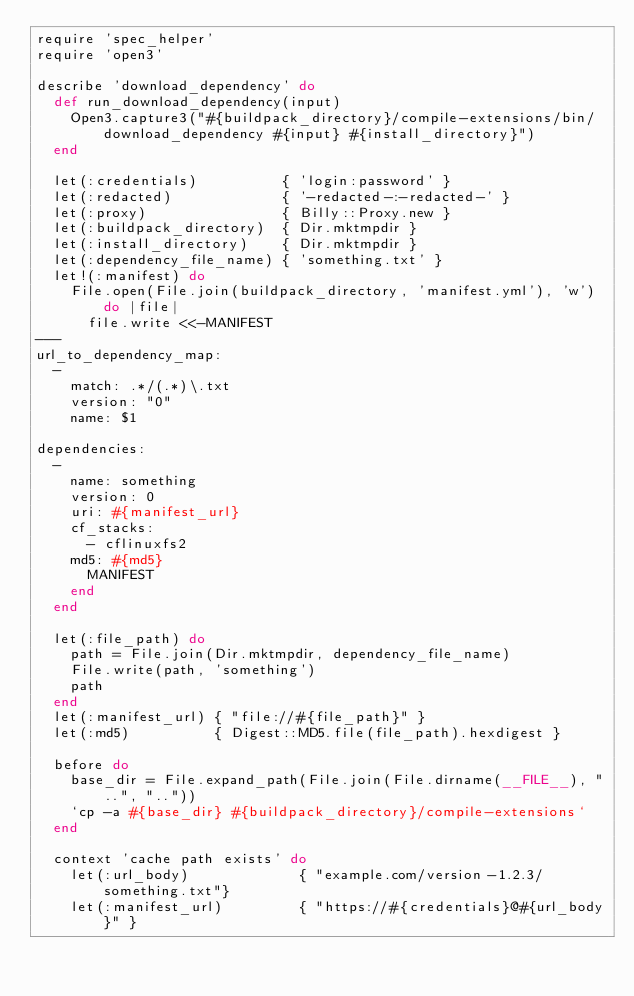Convert code to text. <code><loc_0><loc_0><loc_500><loc_500><_Ruby_>require 'spec_helper'
require 'open3'

describe 'download_dependency' do
  def run_download_dependency(input)
    Open3.capture3("#{buildpack_directory}/compile-extensions/bin/download_dependency #{input} #{install_directory}")
  end

  let(:credentials)          { 'login:password' }
  let(:redacted)             { '-redacted-:-redacted-' }
  let(:proxy)                { Billy::Proxy.new }
  let(:buildpack_directory)  { Dir.mktmpdir }
  let(:install_directory)    { Dir.mktmpdir }
  let(:dependency_file_name) { 'something.txt' }
  let!(:manifest) do
    File.open(File.join(buildpack_directory, 'manifest.yml'), 'w') do |file|
      file.write <<-MANIFEST
---
url_to_dependency_map:
  -
    match: .*/(.*)\.txt
    version: "0"
    name: $1

dependencies:
  -
    name: something
    version: 0
    uri: #{manifest_url}
    cf_stacks:
      - cflinuxfs2
    md5: #{md5}
      MANIFEST
    end
  end

  let(:file_path) do
    path = File.join(Dir.mktmpdir, dependency_file_name)
    File.write(path, 'something')
    path
  end
  let(:manifest_url) { "file://#{file_path}" }
  let(:md5)          { Digest::MD5.file(file_path).hexdigest }

  before do
    base_dir = File.expand_path(File.join(File.dirname(__FILE__), "..", ".."))
    `cp -a #{base_dir} #{buildpack_directory}/compile-extensions`
  end

  context 'cache path exists' do
    let(:url_body)             { "example.com/version-1.2.3/something.txt"}
    let(:manifest_url)         { "https://#{credentials}@#{url_body}" }</code> 